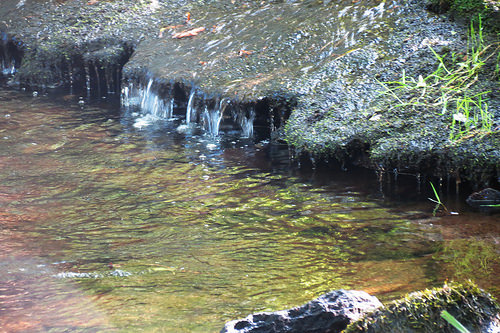<image>
Is there a rock in the water? Yes. The rock is contained within or inside the water, showing a containment relationship. Is the rock above the water? Yes. The rock is positioned above the water in the vertical space, higher up in the scene. 